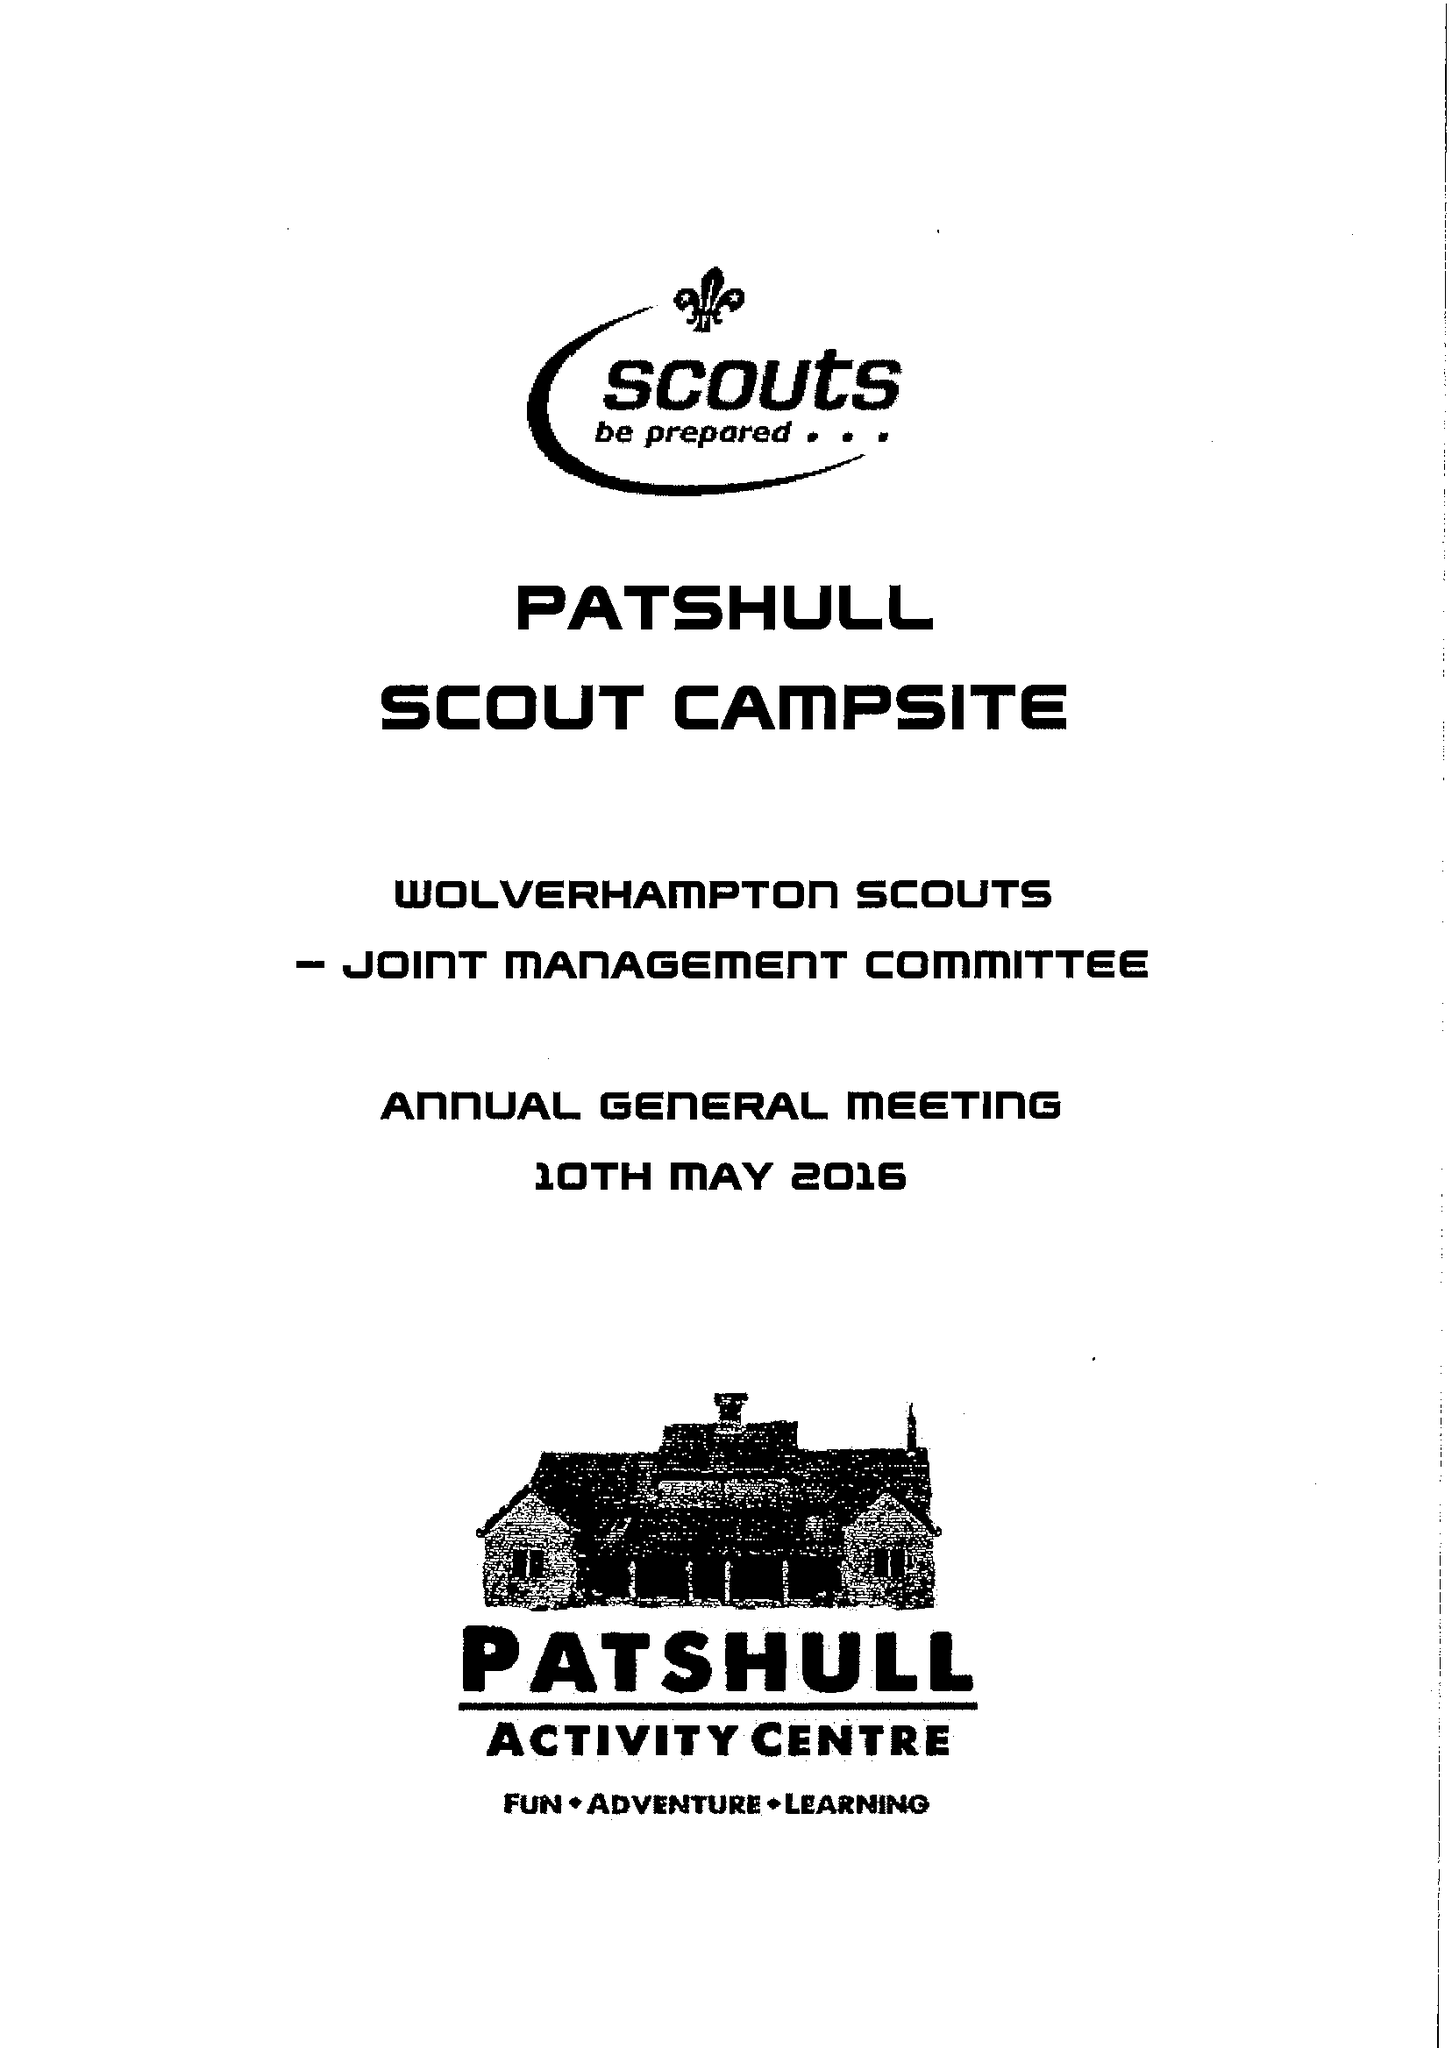What is the value for the charity_number?
Answer the question using a single word or phrase. 518018 